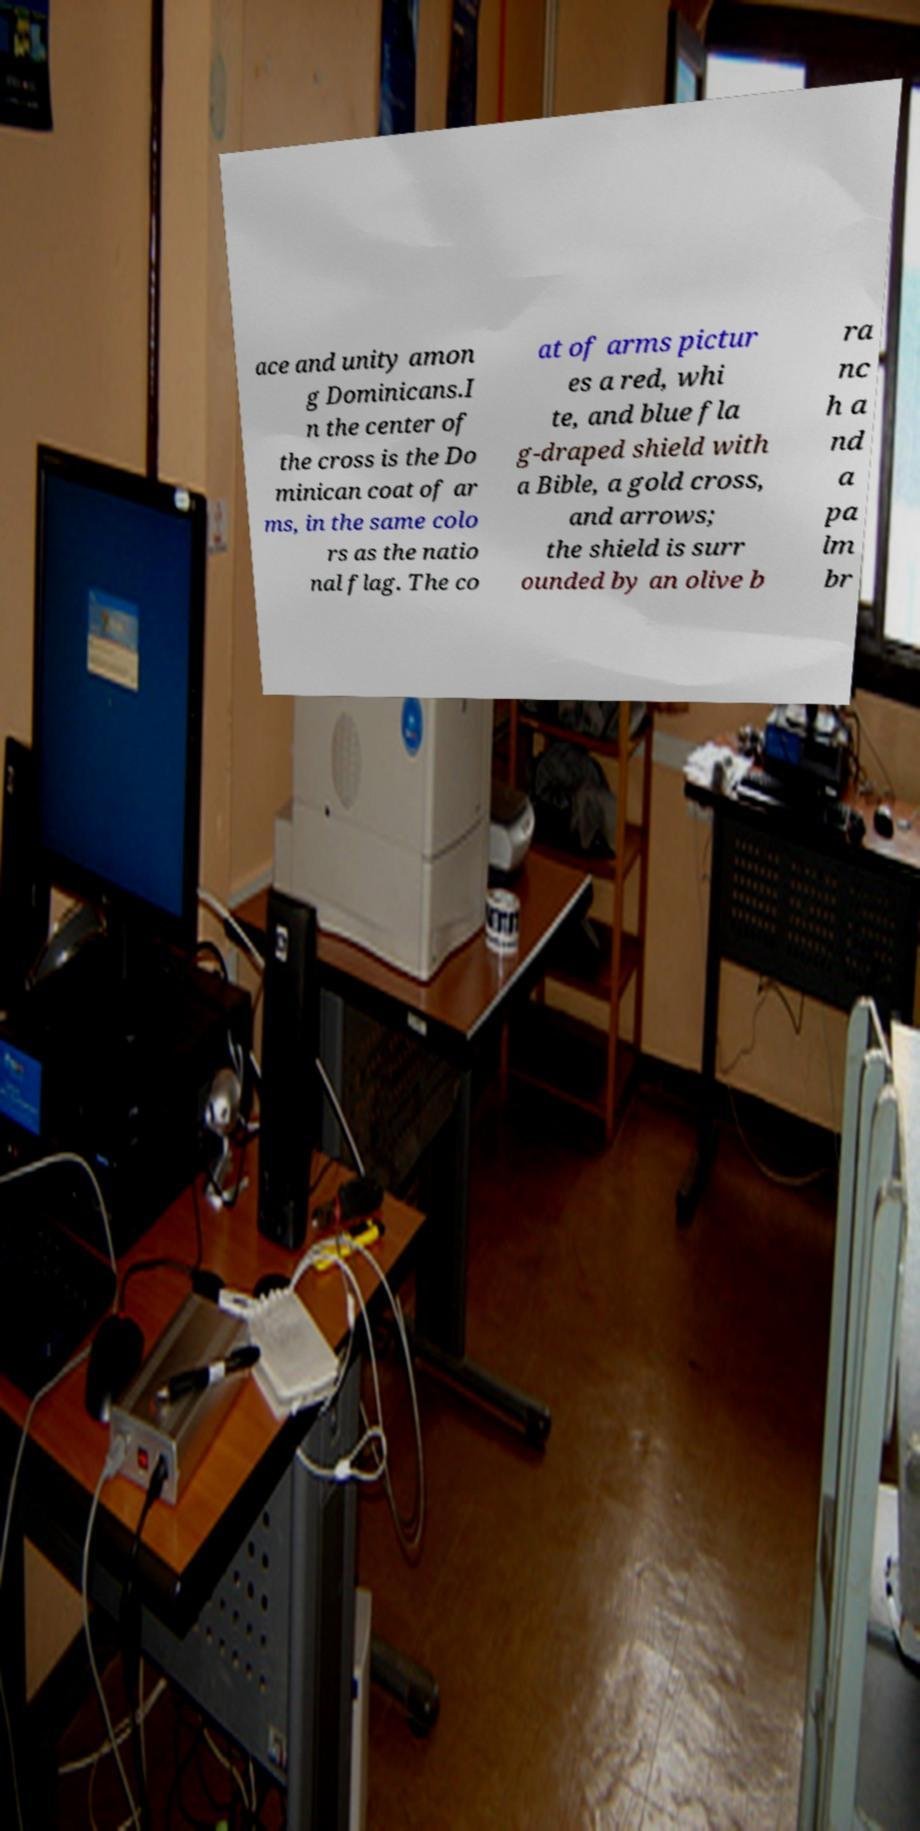Please read and relay the text visible in this image. What does it say? ace and unity amon g Dominicans.I n the center of the cross is the Do minican coat of ar ms, in the same colo rs as the natio nal flag. The co at of arms pictur es a red, whi te, and blue fla g-draped shield with a Bible, a gold cross, and arrows; the shield is surr ounded by an olive b ra nc h a nd a pa lm br 